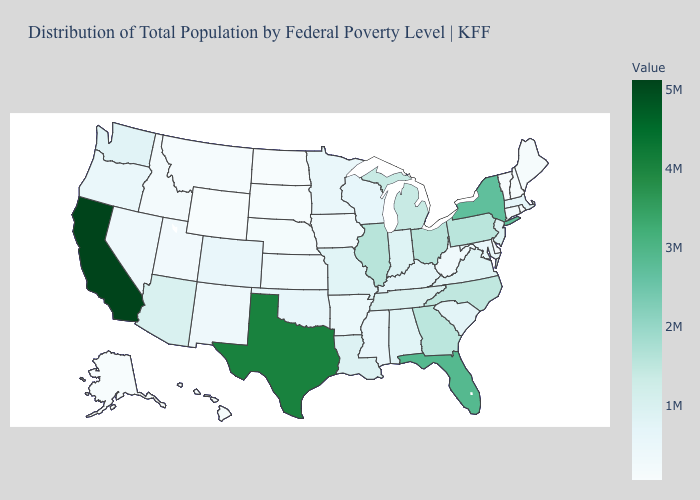Does Washington have the lowest value in the West?
Be succinct. No. Does Vermont have the lowest value in the Northeast?
Answer briefly. Yes. Does Pennsylvania have the highest value in the Northeast?
Write a very short answer. No. Does Illinois have the highest value in the MidWest?
Write a very short answer. Yes. Which states have the lowest value in the USA?
Answer briefly. Wyoming. Does Indiana have a higher value than Pennsylvania?
Give a very brief answer. No. 